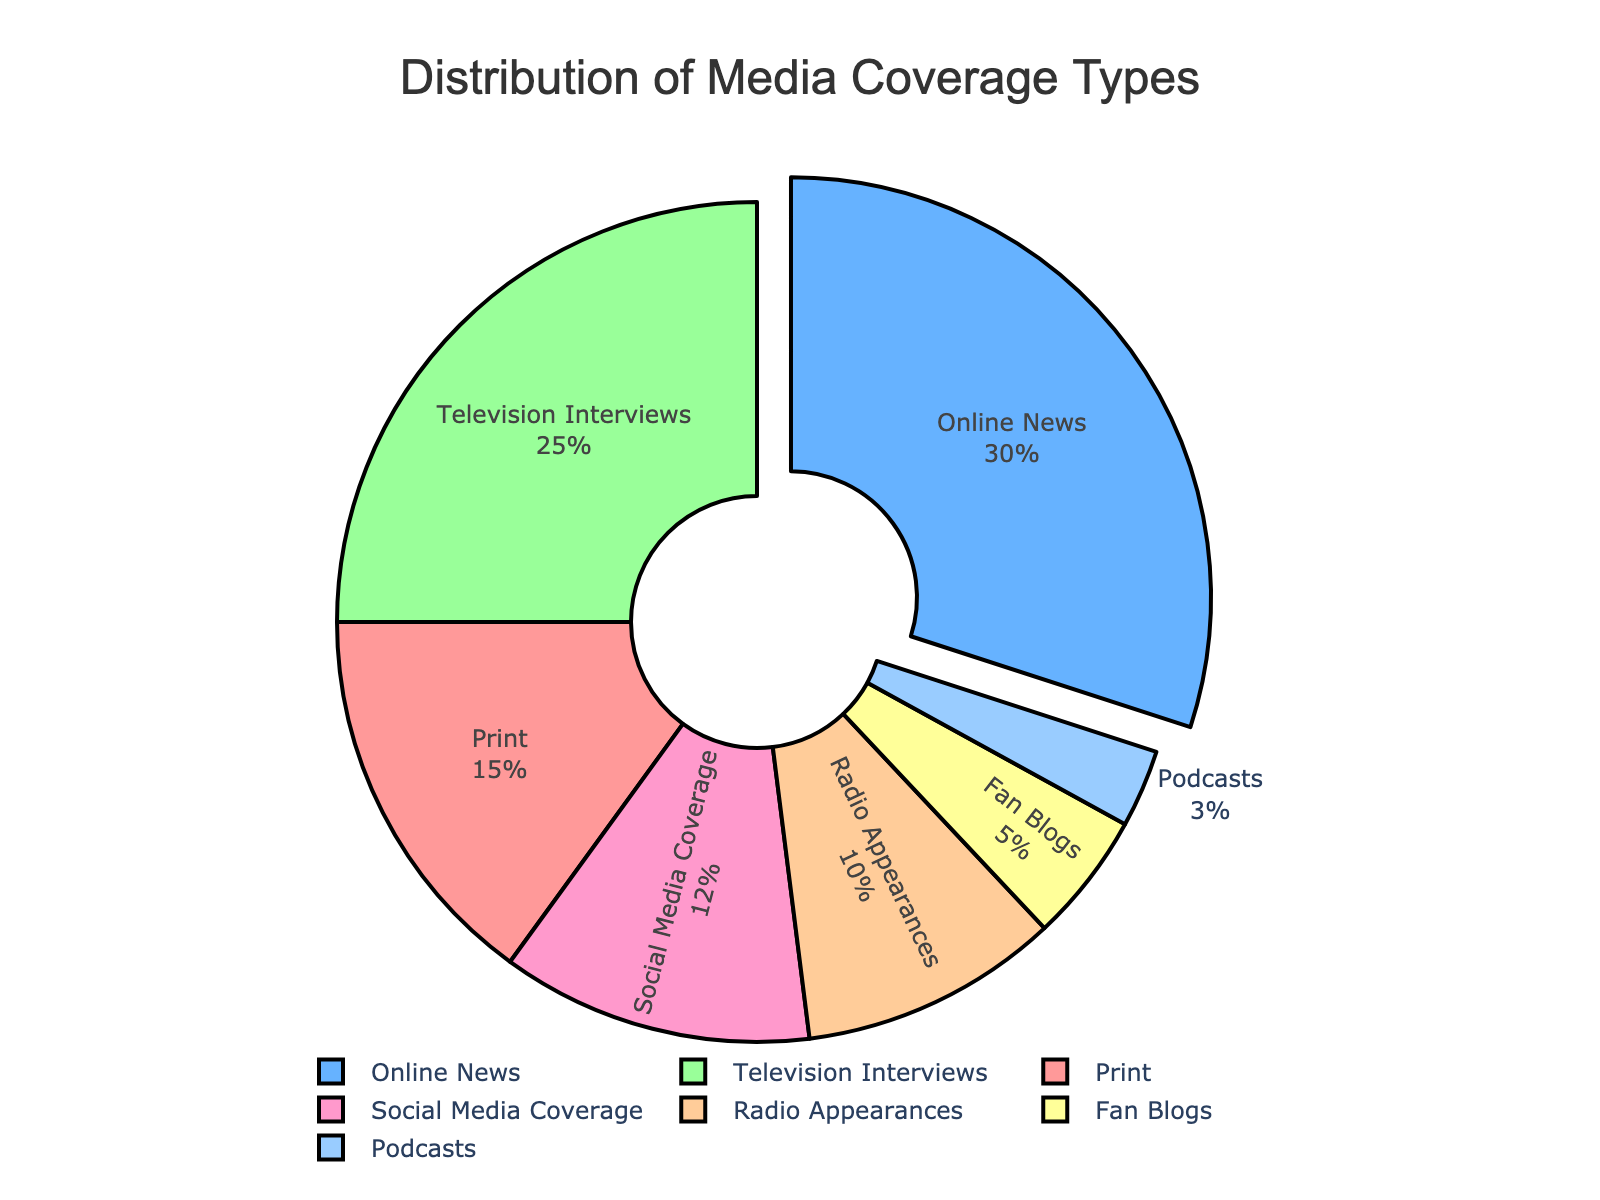What's the largest segment in the pie chart? The largest segment in the pie chart is identified by the larger area and is usually slightly pulled out in this specific pie chart. It indicates the segment with the highest percentage. Observing the chart, the 'Online News' segment has the largest area and is slightly pulled out, indicating it as the largest.
Answer: Online News What's the total percentage of Print and Radio Appearances coverage types combined? To find the total percentage of Print and Radio Appearances, sum their individual percentages by referring to the figure. Print covers 15% and Radio Appearances cover 10%. Adding these together gives: 15% + 10% = 25%.
Answer: 25% Which media type has the second highest percentage of coverage? The second largest segment can be identified by size after the largest one. Observing the chart, the largest segment is 'Online News' at 30%. The next largest is 'Television Interviews' at 25%.
Answer: Television Interviews What's the difference between the highest and lowest coverage types? The highest percentage is 'Online News' at 30%, and the lowest is 'Podcasts' at 3%. The difference is calculated by subtracting the lowest percentage from the highest: 30% - 3% = 27%.
Answer: 27% Which media coverage type is represented by the yellow segment, and what percentage does it represent? The yellow segment of the pie can be identified by its distinct color. Observing the chart, the yellow segment corresponds to 'Television Interviews' with a coverage percentage of 25%.
Answer: Television Interviews, 25% What is the proportion of social media-related coverage (Social Media Coverage and Fan Blogs) to the total coverage? To find the combined social media-related coverage, add the percentages of 'Social Media Coverage' and 'Fan Blogs': 12% + 5% = 17%. Since the total coverage sums to 100%, the proportion is 17%/100%.
Answer: 17% Arrange the media types in descending order of their coverage percentages. To arrange in descending order, list the media types starting from the largest percentage to the smallest: 'Online News' (30%), 'Television Interviews' (25%), 'Print' (15%), 'Social Media Coverage' (12%), 'Radio Appearances' (10%), 'Fan Blogs' (5%), and 'Podcasts' (3%).
Answer: Online News, Television Interviews, Print, Social Media Coverage, Radio Appearances, Fan Blogs, Podcasts Is the percentage of Print coverage greater than the combined percentage of Fan Blogs and Podcasts? To compare, first add the percentages of Fan Blogs and Podcasts: 5% + 3% = 8%. Then compare it with Print coverage: 15% > 8%, so Print coverage is greater.
Answer: Yes Which media types constitute at least 20% of the total coverage? To determine which media types meet or exceed 20%, observe their percentages. Both 'Online News' (30%) and 'Television Interviews' (25%) meet this criterion.
Answer: Online News, Television Interviews If an actor shifts 5% of their Radio Appearances to Social Media Coverage, what will be the new percentage for Social Media Coverage, and will it surpass Print coverage? First, add 5% to the current Social Media Coverage: 12% + 5% = 17%. The new percentage for Social Media Coverage is 17%. Comparing it with Print coverage (15%), Social Media Coverage now surpasses Print coverage.
Answer: 17%, Yes 